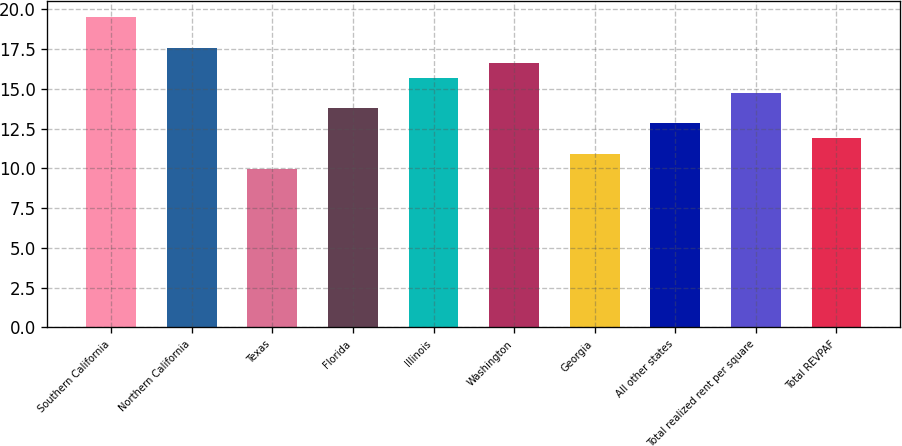Convert chart. <chart><loc_0><loc_0><loc_500><loc_500><bar_chart><fcel>Southern California<fcel>Northern California<fcel>Texas<fcel>Florida<fcel>Illinois<fcel>Washington<fcel>Georgia<fcel>All other states<fcel>Total realized rent per square<fcel>Total REVPAF<nl><fcel>19.52<fcel>17.6<fcel>9.97<fcel>13.79<fcel>15.7<fcel>16.65<fcel>10.93<fcel>12.84<fcel>14.74<fcel>11.88<nl></chart> 